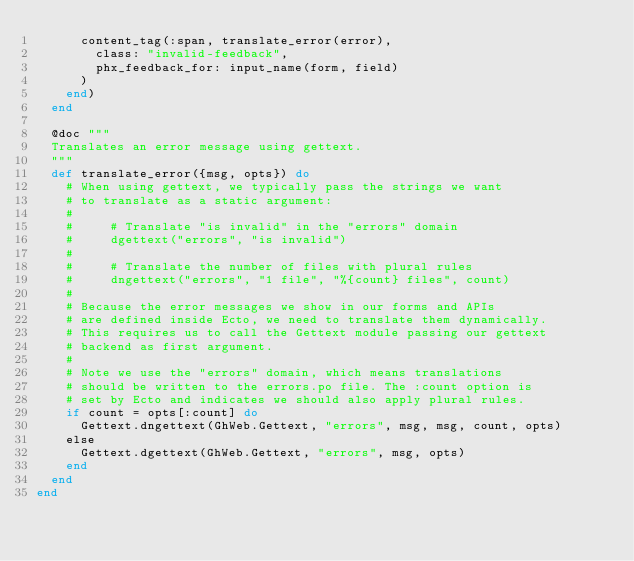<code> <loc_0><loc_0><loc_500><loc_500><_Elixir_>      content_tag(:span, translate_error(error),
        class: "invalid-feedback",
        phx_feedback_for: input_name(form, field)
      )
    end)
  end

  @doc """
  Translates an error message using gettext.
  """
  def translate_error({msg, opts}) do
    # When using gettext, we typically pass the strings we want
    # to translate as a static argument:
    #
    #     # Translate "is invalid" in the "errors" domain
    #     dgettext("errors", "is invalid")
    #
    #     # Translate the number of files with plural rules
    #     dngettext("errors", "1 file", "%{count} files", count)
    #
    # Because the error messages we show in our forms and APIs
    # are defined inside Ecto, we need to translate them dynamically.
    # This requires us to call the Gettext module passing our gettext
    # backend as first argument.
    #
    # Note we use the "errors" domain, which means translations
    # should be written to the errors.po file. The :count option is
    # set by Ecto and indicates we should also apply plural rules.
    if count = opts[:count] do
      Gettext.dngettext(GhWeb.Gettext, "errors", msg, msg, count, opts)
    else
      Gettext.dgettext(GhWeb.Gettext, "errors", msg, opts)
    end
  end
end
</code> 